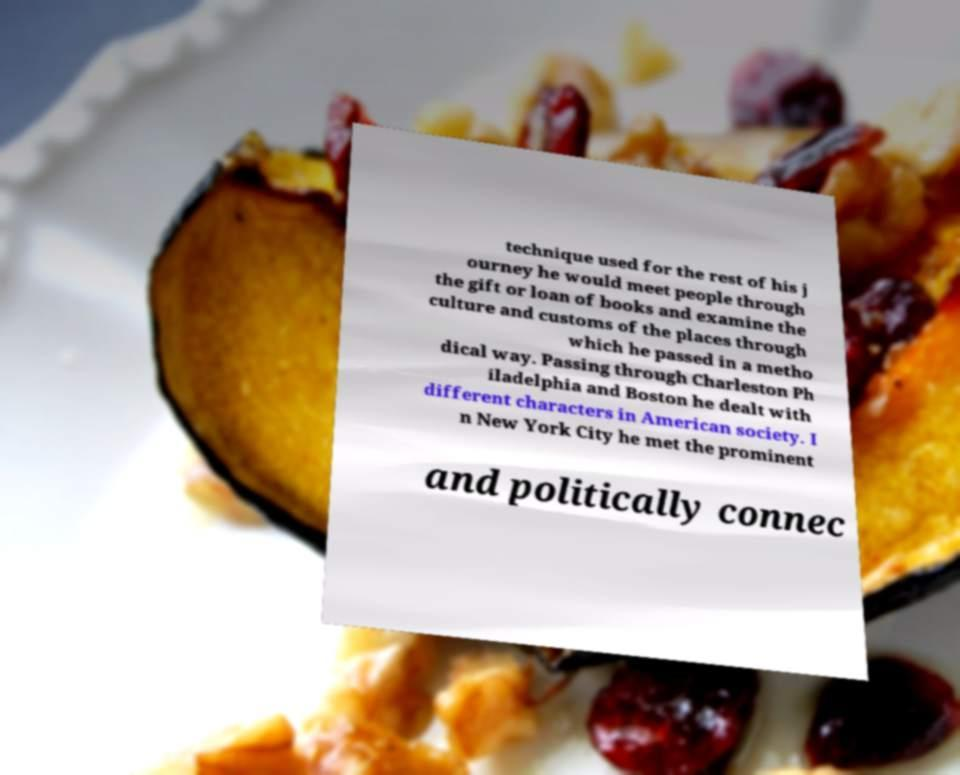Please read and relay the text visible in this image. What does it say? technique used for the rest of his j ourney he would meet people through the gift or loan of books and examine the culture and customs of the places through which he passed in a metho dical way. Passing through Charleston Ph iladelphia and Boston he dealt with different characters in American society. I n New York City he met the prominent and politically connec 